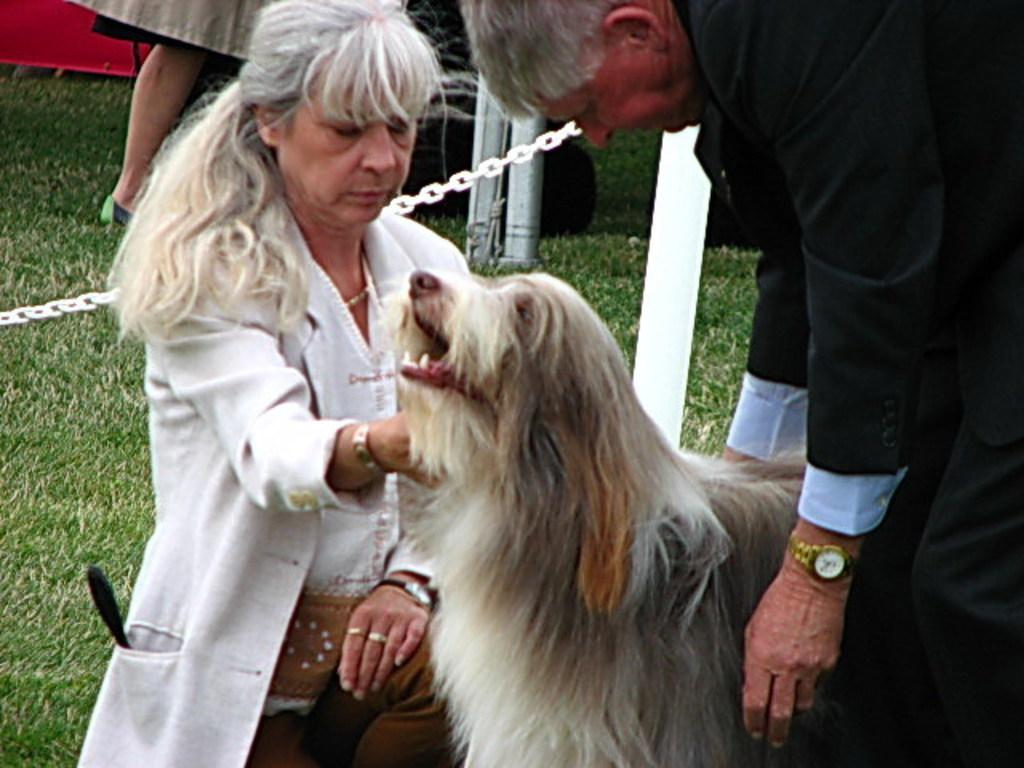Who is the main subject in the image? There is a woman in the image. What is the woman wearing? The woman is wearing a white jacket. What is the woman holding in the image? The woman is holding a dog. Can you describe the person standing behind the dog? The person standing behind the dog is wearing a black suit. What type of terrain is visible in the image? There is grass in the image. Can you describe the person standing far away in the image? There is a person standing far away in the image, but no specific details about their appearance are provided. What type of fiction is the woman reading to the rat in the image? There is no rat present in the image, and the woman is not reading any fiction. 